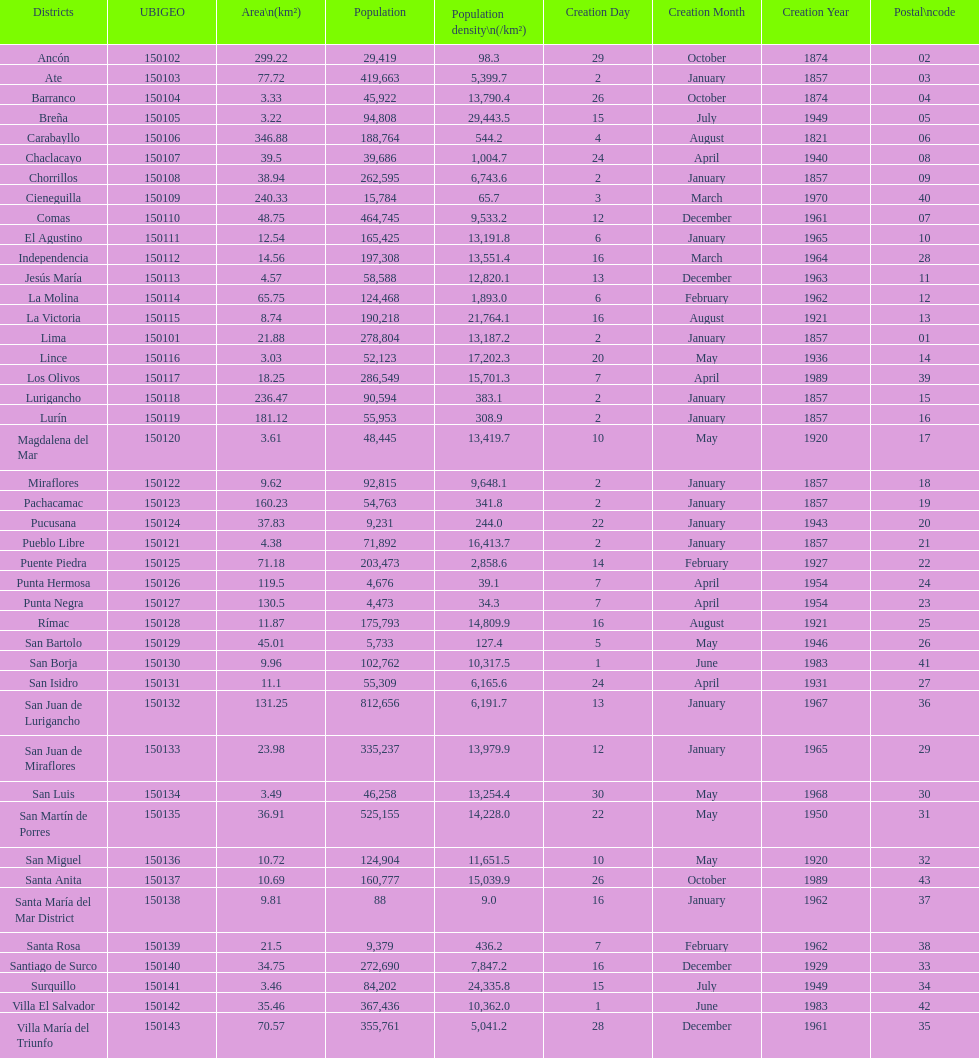Parse the table in full. {'header': ['Districts', 'UBIGEO', 'Area\\n(km²)', 'Population', 'Population density\\n(/km²)', 'Creation Day', 'Creation Month', 'Creation Year', 'Postal\\ncode'], 'rows': [['Ancón', '150102', '299.22', '29,419', '98.3', '29', 'October', '1874', '02'], ['Ate', '150103', '77.72', '419,663', '5,399.7', '2', 'January', '1857', '03'], ['Barranco', '150104', '3.33', '45,922', '13,790.4', '26', 'October', '1874', '04'], ['Breña', '150105', '3.22', '94,808', '29,443.5', '15', 'July', '1949', '05'], ['Carabayllo', '150106', '346.88', '188,764', '544.2', '4', 'August', '1821', '06'], ['Chaclacayo', '150107', '39.5', '39,686', '1,004.7', '24', 'April', '1940', '08'], ['Chorrillos', '150108', '38.94', '262,595', '6,743.6', '2', 'January', '1857', '09'], ['Cieneguilla', '150109', '240.33', '15,784', '65.7', '3', 'March', '1970', '40'], ['Comas', '150110', '48.75', '464,745', '9,533.2', '12', 'December', '1961', '07'], ['El Agustino', '150111', '12.54', '165,425', '13,191.8', '6', 'January', '1965', '10'], ['Independencia', '150112', '14.56', '197,308', '13,551.4', '16', 'March', '1964', '28'], ['Jesús María', '150113', '4.57', '58,588', '12,820.1', '13', 'December', '1963', '11'], ['La Molina', '150114', '65.75', '124,468', '1,893.0', '6', 'February', '1962', '12'], ['La Victoria', '150115', '8.74', '190,218', '21,764.1', '16', 'August', '1921', '13'], ['Lima', '150101', '21.88', '278,804', '13,187.2', '2', 'January', '1857', '01'], ['Lince', '150116', '3.03', '52,123', '17,202.3', '20', 'May', '1936', '14'], ['Los Olivos', '150117', '18.25', '286,549', '15,701.3', '7', 'April', '1989', '39'], ['Lurigancho', '150118', '236.47', '90,594', '383.1', '2', 'January', '1857', '15'], ['Lurín', '150119', '181.12', '55,953', '308.9', '2', 'January', '1857', '16'], ['Magdalena del Mar', '150120', '3.61', '48,445', '13,419.7', '10', 'May', '1920', '17'], ['Miraflores', '150122', '9.62', '92,815', '9,648.1', '2', 'January', '1857', '18'], ['Pachacamac', '150123', '160.23', '54,763', '341.8', '2', 'January', '1857', '19'], ['Pucusana', '150124', '37.83', '9,231', '244.0', '22', 'January', '1943', '20'], ['Pueblo Libre', '150121', '4.38', '71,892', '16,413.7', '2', 'January', '1857', '21'], ['Puente Piedra', '150125', '71.18', '203,473', '2,858.6', '14', 'February', '1927', '22'], ['Punta Hermosa', '150126', '119.5', '4,676', '39.1', '7', 'April', '1954', '24'], ['Punta Negra', '150127', '130.5', '4,473', '34.3', '7', 'April', '1954', '23'], ['Rímac', '150128', '11.87', '175,793', '14,809.9', '16', 'August', '1921', '25'], ['San Bartolo', '150129', '45.01', '5,733', '127.4', '5', 'May', '1946', '26'], ['San Borja', '150130', '9.96', '102,762', '10,317.5', '1', 'June', '1983', '41'], ['San Isidro', '150131', '11.1', '55,309', '6,165.6', '24', 'April', '1931', '27'], ['San Juan de Lurigancho', '150132', '131.25', '812,656', '6,191.7', '13', 'January', '1967', '36'], ['San Juan de Miraflores', '150133', '23.98', '335,237', '13,979.9', '12', 'January', '1965', '29'], ['San Luis', '150134', '3.49', '46,258', '13,254.4', '30', 'May', '1968', '30'], ['San Martín de Porres', '150135', '36.91', '525,155', '14,228.0', '22', 'May', '1950', '31'], ['San Miguel', '150136', '10.72', '124,904', '11,651.5', '10', 'May', '1920', '32'], ['Santa Anita', '150137', '10.69', '160,777', '15,039.9', '26', 'October', '1989', '43'], ['Santa María del Mar District', '150138', '9.81', '88', '9.0', '16', 'January', '1962', '37'], ['Santa Rosa', '150139', '21.5', '9,379', '436.2', '7', 'February', '1962', '38'], ['Santiago de Surco', '150140', '34.75', '272,690', '7,847.2', '16', 'December', '1929', '33'], ['Surquillo', '150141', '3.46', '84,202', '24,335.8', '15', 'July', '1949', '34'], ['Villa El Salvador', '150142', '35.46', '367,436', '10,362.0', '1', 'June', '1983', '42'], ['Villa María del Triunfo', '150143', '70.57', '355,761', '5,041.2', '28', 'December', '1961', '35']]} How many districts have more than 100,000 people in this city? 21. 